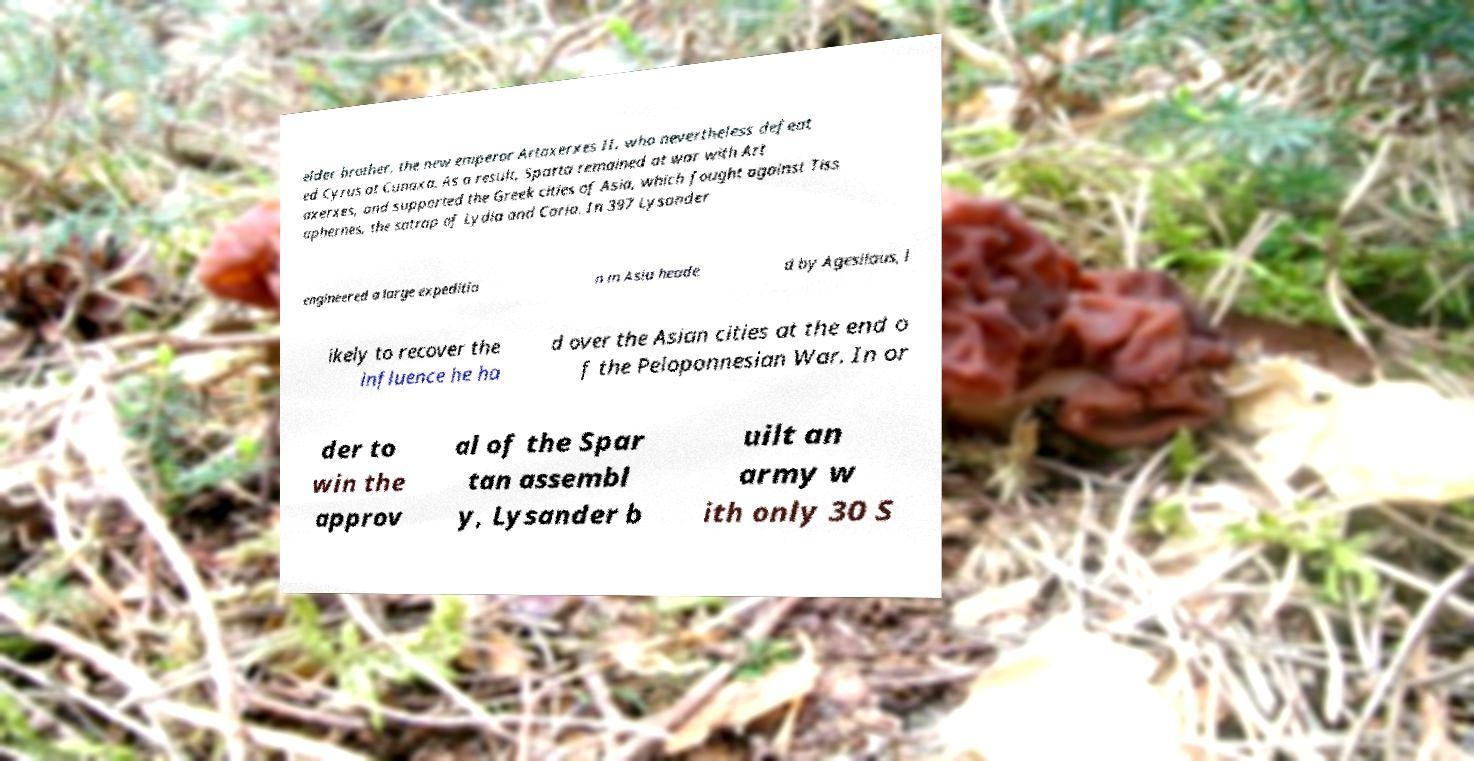Please read and relay the text visible in this image. What does it say? elder brother, the new emperor Artaxerxes II, who nevertheless defeat ed Cyrus at Cunaxa. As a result, Sparta remained at war with Art axerxes, and supported the Greek cities of Asia, which fought against Tiss aphernes, the satrap of Lydia and Caria. In 397 Lysander engineered a large expeditio n in Asia heade d by Agesilaus, l ikely to recover the influence he ha d over the Asian cities at the end o f the Peloponnesian War. In or der to win the approv al of the Spar tan assembl y, Lysander b uilt an army w ith only 30 S 